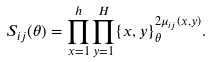Convert formula to latex. <formula><loc_0><loc_0><loc_500><loc_500>S _ { i j } ( \theta ) = \prod _ { x = 1 } ^ { h } \prod _ { y = 1 } ^ { H } \{ x , y \} _ { \theta } ^ { 2 \mu _ { i j } ( x , y ) } .</formula> 